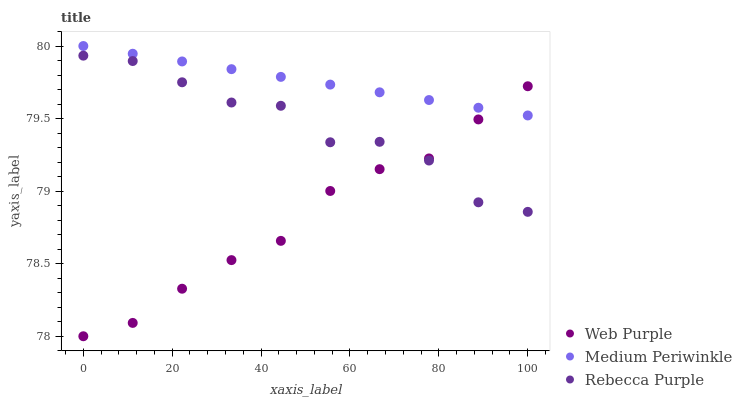Does Web Purple have the minimum area under the curve?
Answer yes or no. Yes. Does Medium Periwinkle have the maximum area under the curve?
Answer yes or no. Yes. Does Rebecca Purple have the minimum area under the curve?
Answer yes or no. No. Does Rebecca Purple have the maximum area under the curve?
Answer yes or no. No. Is Medium Periwinkle the smoothest?
Answer yes or no. Yes. Is Rebecca Purple the roughest?
Answer yes or no. Yes. Is Rebecca Purple the smoothest?
Answer yes or no. No. Is Medium Periwinkle the roughest?
Answer yes or no. No. Does Web Purple have the lowest value?
Answer yes or no. Yes. Does Rebecca Purple have the lowest value?
Answer yes or no. No. Does Medium Periwinkle have the highest value?
Answer yes or no. Yes. Does Rebecca Purple have the highest value?
Answer yes or no. No. Is Rebecca Purple less than Medium Periwinkle?
Answer yes or no. Yes. Is Medium Periwinkle greater than Rebecca Purple?
Answer yes or no. Yes. Does Web Purple intersect Rebecca Purple?
Answer yes or no. Yes. Is Web Purple less than Rebecca Purple?
Answer yes or no. No. Is Web Purple greater than Rebecca Purple?
Answer yes or no. No. Does Rebecca Purple intersect Medium Periwinkle?
Answer yes or no. No. 